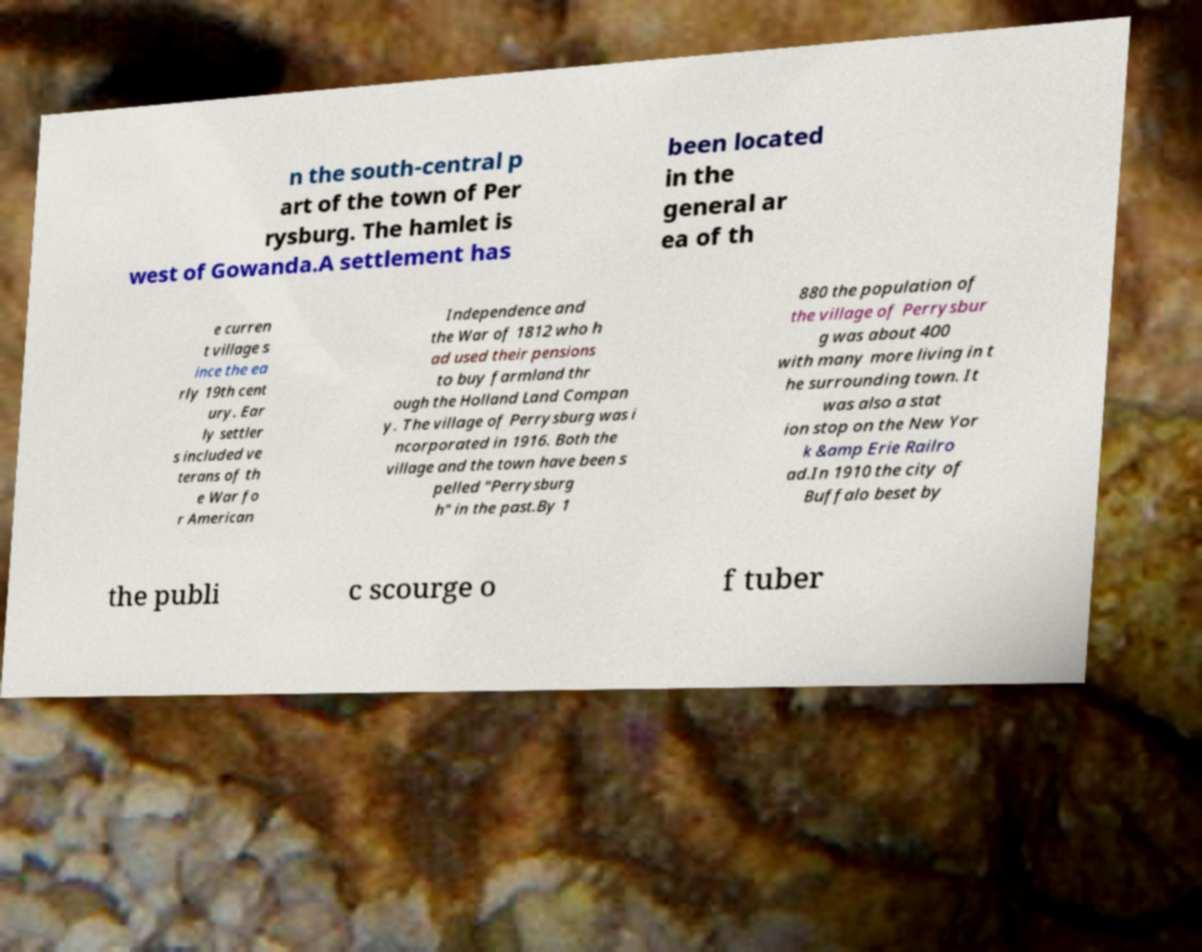Please read and relay the text visible in this image. What does it say? n the south-central p art of the town of Per rysburg. The hamlet is west of Gowanda.A settlement has been located in the general ar ea of th e curren t village s ince the ea rly 19th cent ury. Ear ly settler s included ve terans of th e War fo r American Independence and the War of 1812 who h ad used their pensions to buy farmland thr ough the Holland Land Compan y. The village of Perrysburg was i ncorporated in 1916. Both the village and the town have been s pelled "Perrysburg h" in the past.By 1 880 the population of the village of Perrysbur g was about 400 with many more living in t he surrounding town. It was also a stat ion stop on the New Yor k &amp Erie Railro ad.In 1910 the city of Buffalo beset by the publi c scourge o f tuber 